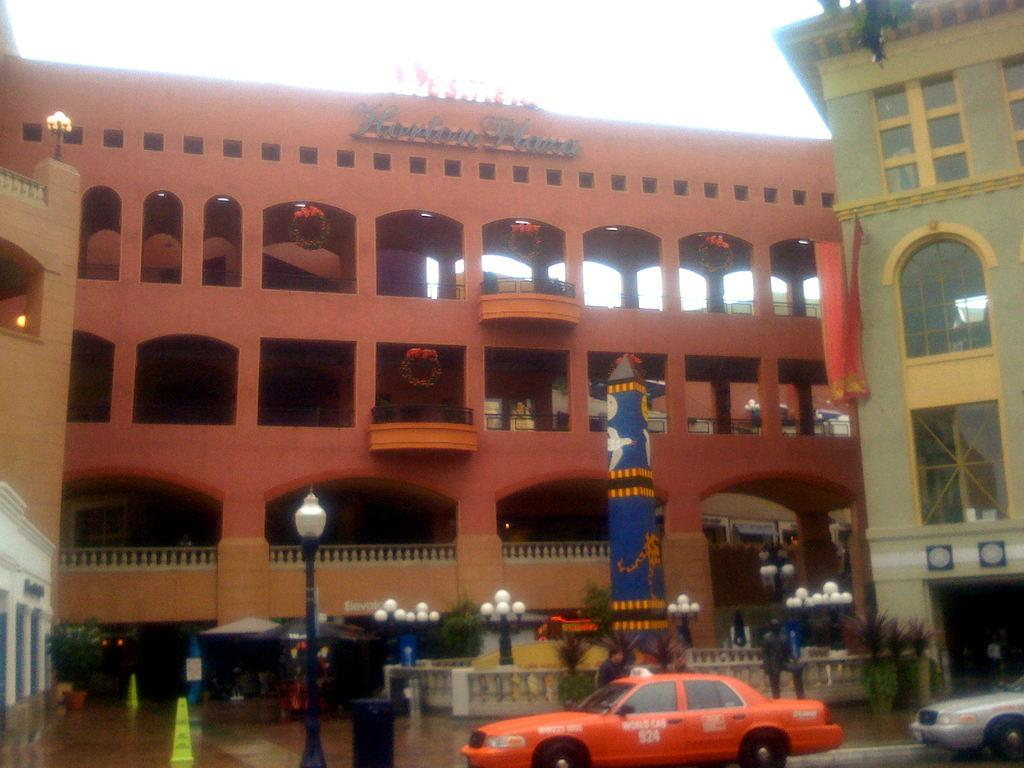Provide a one-sentence caption for the provided image. An orange WORLD CAB number 924 sits in front of a building. 